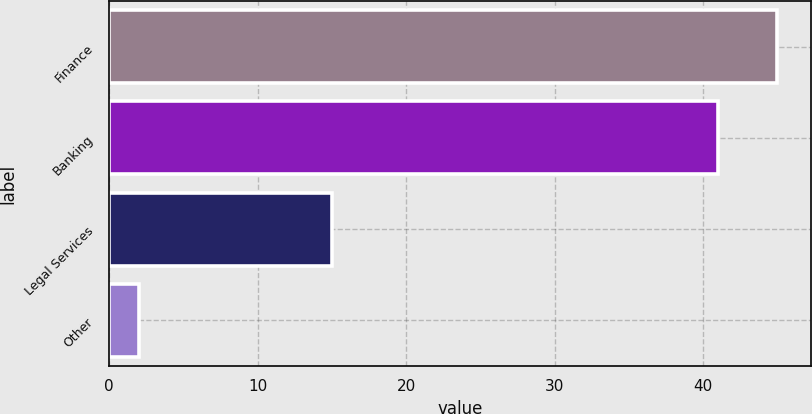Convert chart. <chart><loc_0><loc_0><loc_500><loc_500><bar_chart><fcel>Finance<fcel>Banking<fcel>Legal Services<fcel>Other<nl><fcel>45<fcel>41<fcel>15<fcel>2<nl></chart> 